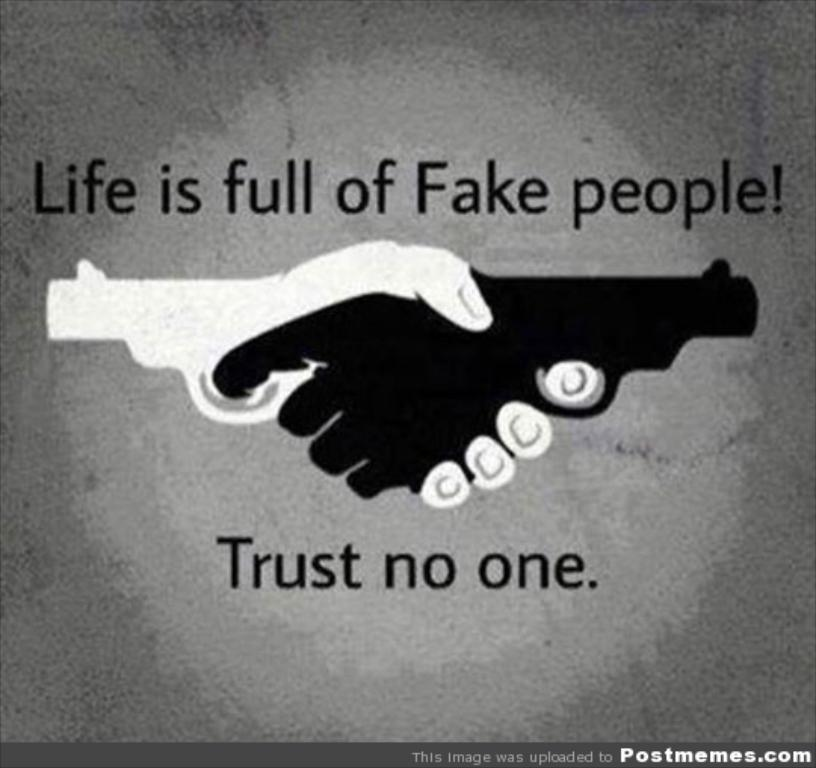<image>
Create a compact narrative representing the image presented. The phrase trust no one can be seen below two hands grasping each other. 